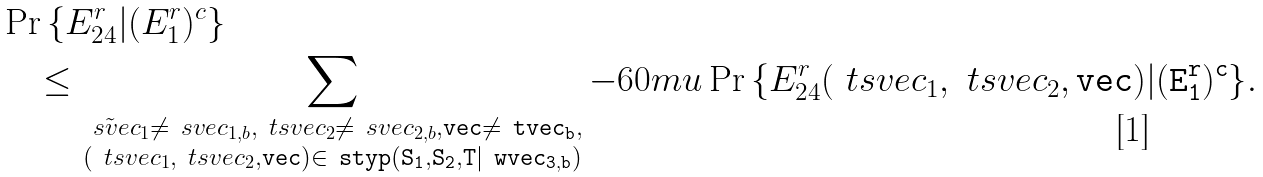Convert formula to latex. <formula><loc_0><loc_0><loc_500><loc_500>& \Pr \left \{ E _ { 2 4 } ^ { r } | ( E _ { 1 } ^ { r } ) ^ { c } \right \} \\ & \quad \leq \sum _ { \substack { \tilde { \ s v e c } _ { 1 } \neq \ s v e c _ { 1 , b } , \ t s v e c _ { 2 } \neq \ s v e c _ { 2 , b } , \tt v e c \ne \ t v e c _ { b } , \\ ( \ t s v e c _ { 1 } , \ t s v e c _ { 2 } , \tt v e c ) \in \ s t y p ( S _ { 1 } , S _ { 2 } , T | \ w v e c _ { 3 , b } ) } } { { - 6 0 m u } \Pr \left \{ E _ { 2 4 } ^ { r } ( \ t s v e c _ { 1 } , \ t s v e c _ { 2 } , \tt v e c ) | ( E _ { 1 } ^ { r } ) ^ { c } \right \} } .</formula> 